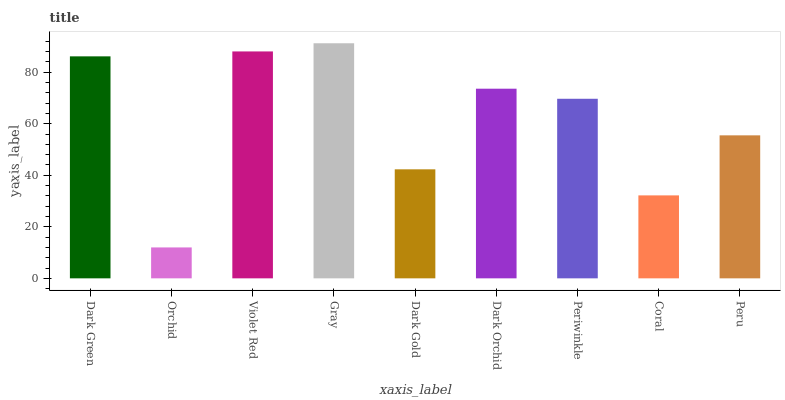Is Orchid the minimum?
Answer yes or no. Yes. Is Gray the maximum?
Answer yes or no. Yes. Is Violet Red the minimum?
Answer yes or no. No. Is Violet Red the maximum?
Answer yes or no. No. Is Violet Red greater than Orchid?
Answer yes or no. Yes. Is Orchid less than Violet Red?
Answer yes or no. Yes. Is Orchid greater than Violet Red?
Answer yes or no. No. Is Violet Red less than Orchid?
Answer yes or no. No. Is Periwinkle the high median?
Answer yes or no. Yes. Is Periwinkle the low median?
Answer yes or no. Yes. Is Coral the high median?
Answer yes or no. No. Is Dark Green the low median?
Answer yes or no. No. 